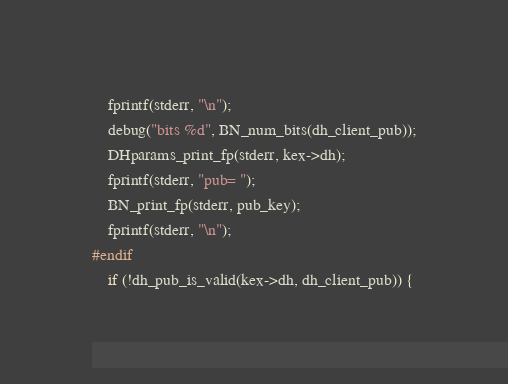Convert code to text. <code><loc_0><loc_0><loc_500><loc_500><_C_>	fprintf(stderr, "\n");
	debug("bits %d", BN_num_bits(dh_client_pub));
	DHparams_print_fp(stderr, kex->dh);
	fprintf(stderr, "pub= ");
	BN_print_fp(stderr, pub_key);
	fprintf(stderr, "\n");
#endif
	if (!dh_pub_is_valid(kex->dh, dh_client_pub)) {</code> 